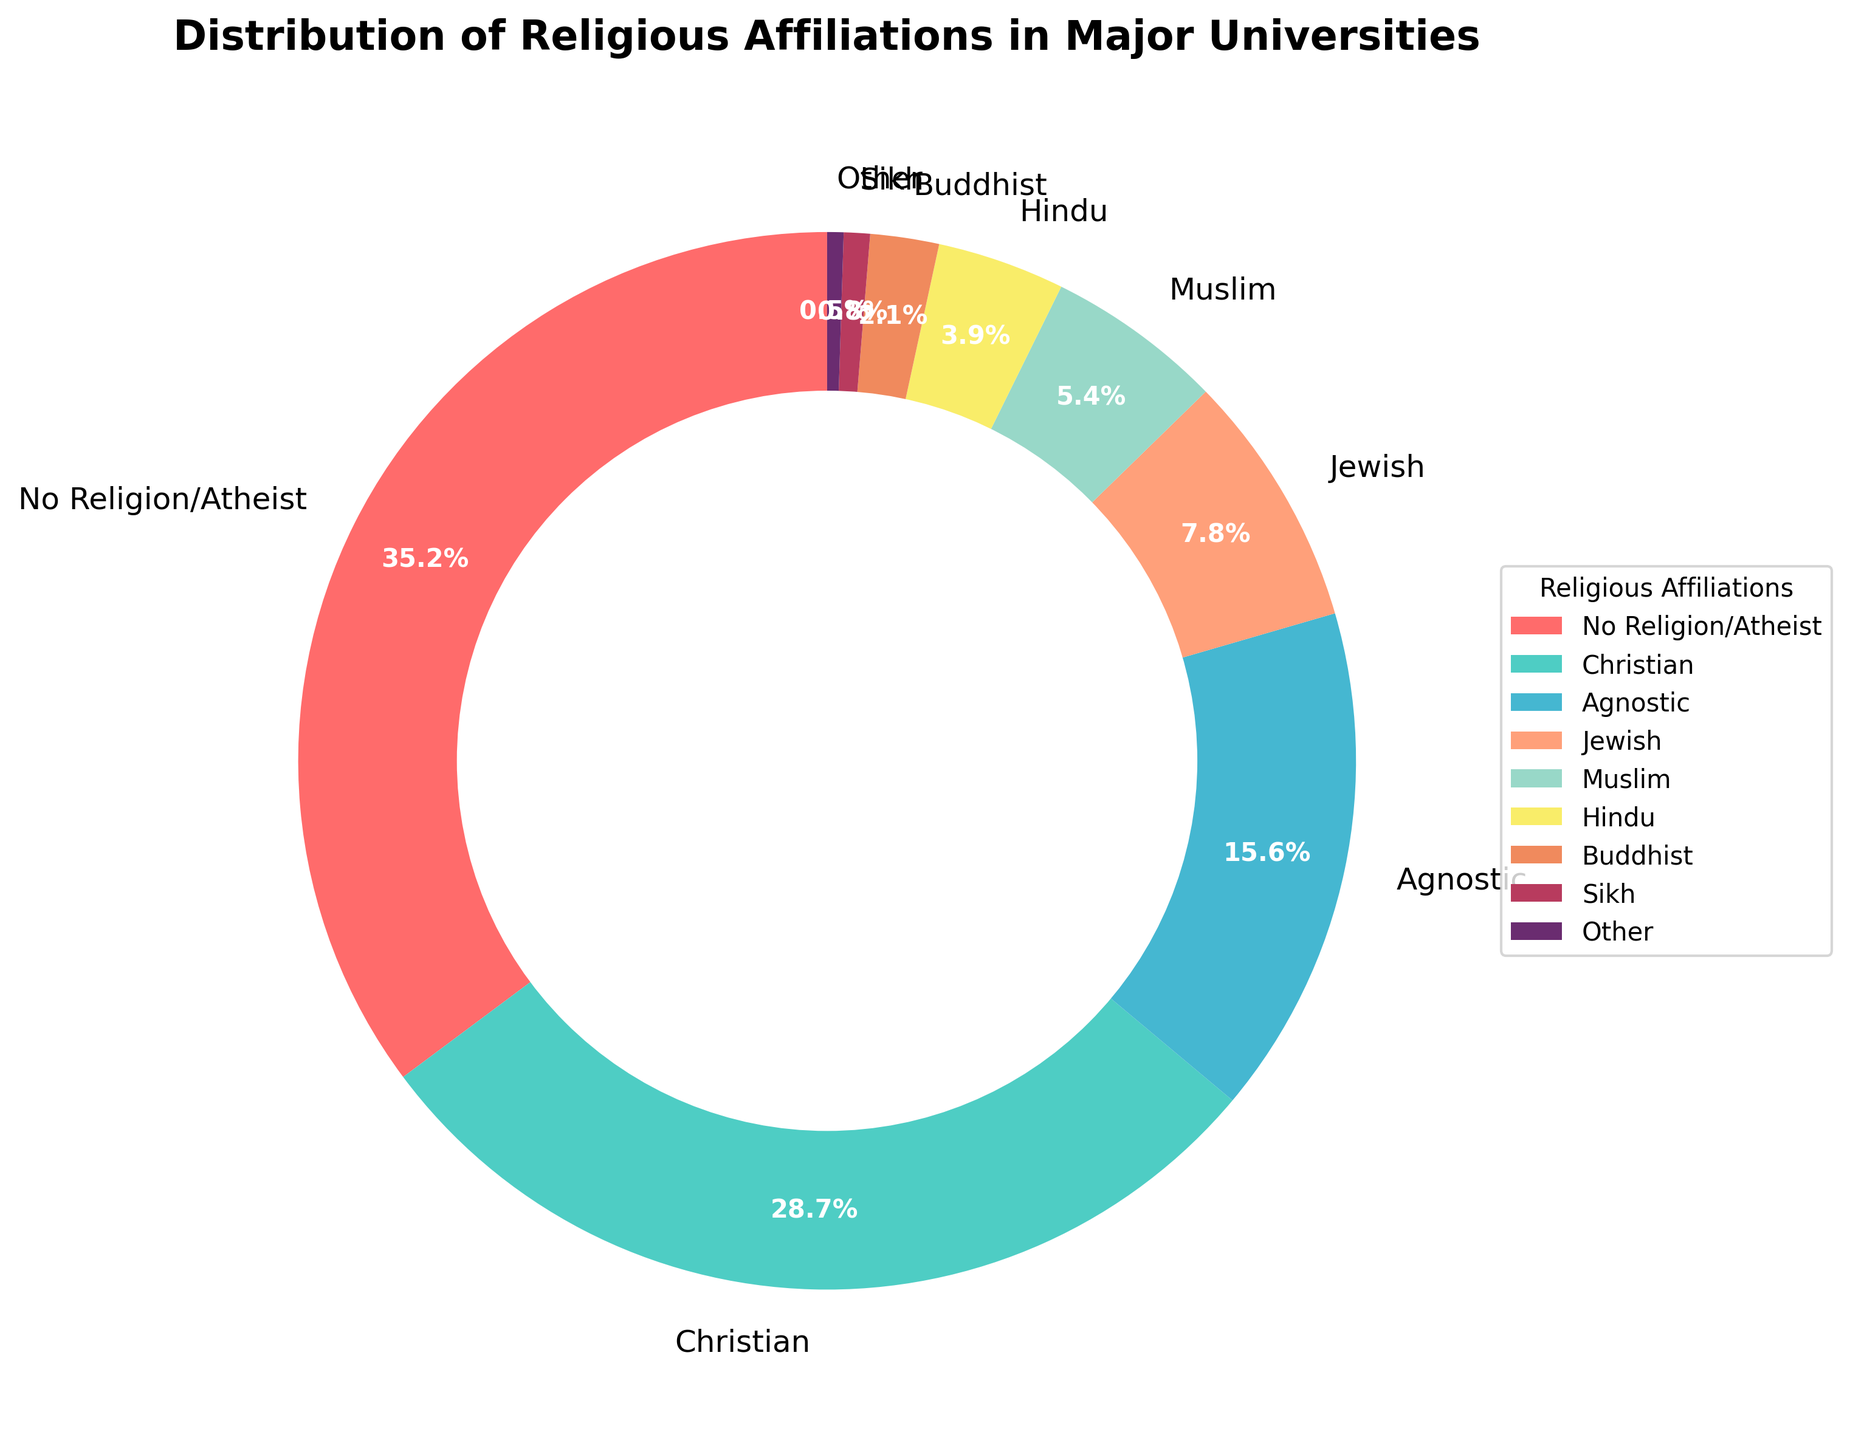What is the percentage of students with no religious affiliation or who are atheist? The chart indicates that an area labeled "No Religion/Atheist" occupies 35.2% of the pie.
Answer: 35.2% Which religious group has the second highest percentage? The chart shows the largest segment is labeled "No Religion/Atheist" at 35.2%, and the next largest segment is labeled "Christian" at 28.7%.
Answer: Christian (28.7%) How much larger is the percentage of No Religion/Atheist compared to Agnostic? The chart shows "No Religion/Atheist" at 35.2% and "Agnostic" at 15.6%. The difference is 35.2 - 15.6.
Answer: 19.6% What is the combined percentage of Muslim, Hindu, Buddhist, and Sikh students? The chart shows percentages for each: Muslim (5.4%), Hindu (3.9%), Buddhist (2.1%), Sikh (0.8%). Adding these gives 5.4 + 3.9 + 2.1 + 0.8.
Answer: 12.2% How does the percentage of Jewish students compare to the percentage of Muslim students? The chart shows Jewish students at 7.8% and Muslim students at 5.4%. Comparing the two, 7.8 is greater than 5.4.
Answer: Jewish > Muslim What is the total percentage of students that belong to either Christian or Jewish groups? The chart indicates Christians make up 28.7% and Jewish students make up 7.8%. Adding these percentages gives 28.7 + 7.8.
Answer: 36.5% Which group has the smallest percentage, and what is it? The smallest segment in the chart is labeled "Other" with a percentage of 0.5%.
Answer: Other (0.5%) Is the percentage of students identifying as Buddhist less than or equal to 3%? The chart indicates the Buddhist segment is labeled 2.1%. Since 2.1 is less than 3, the answer is yes.
Answer: Yes State the groups with purple and yellow segments, and their percentages. The chart shows the purple segment represents 'Sikh' at 0.8%, and the yellow segment is 'Hindu' at 3.9%.
Answer: Sikh (0.8%), Hindu (3.9%) What is the average percentage of Christian, Jewish, and Muslim students? The chart shows Christians at 28.7%, Jewish at 7.8%, and Muslim at 5.4%. The sum is 28.7 + 7.8 + 5.4 = 41.9. The average is 41.9 / 3.
Answer: 13.97% 